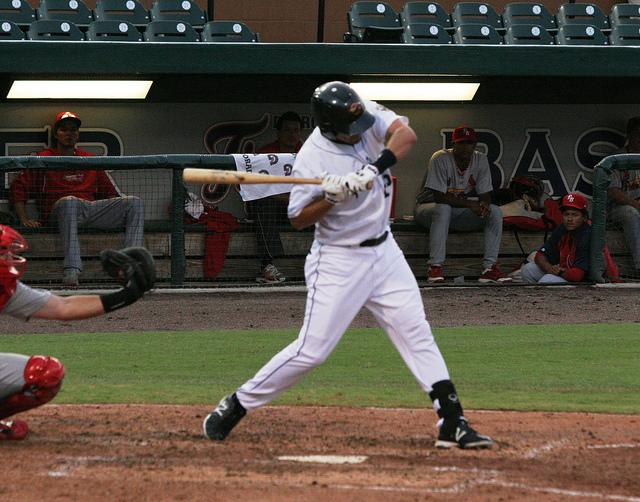What material is the bat?
Concise answer only. Wood. Did he hit the ball?
Answer briefly. No. What brand of shoes is the batter wearing?
Write a very short answer. Nike. Are the stands full?
Give a very brief answer. No. What is the logo on his wristband?
Quick response, please. Nike. What color is the batters hat?
Write a very short answer. Black. Is the batter left handed?
Short answer required. No. What is the man doing?
Be succinct. Swinging bat. What color is the bat?
Concise answer only. Brown. 